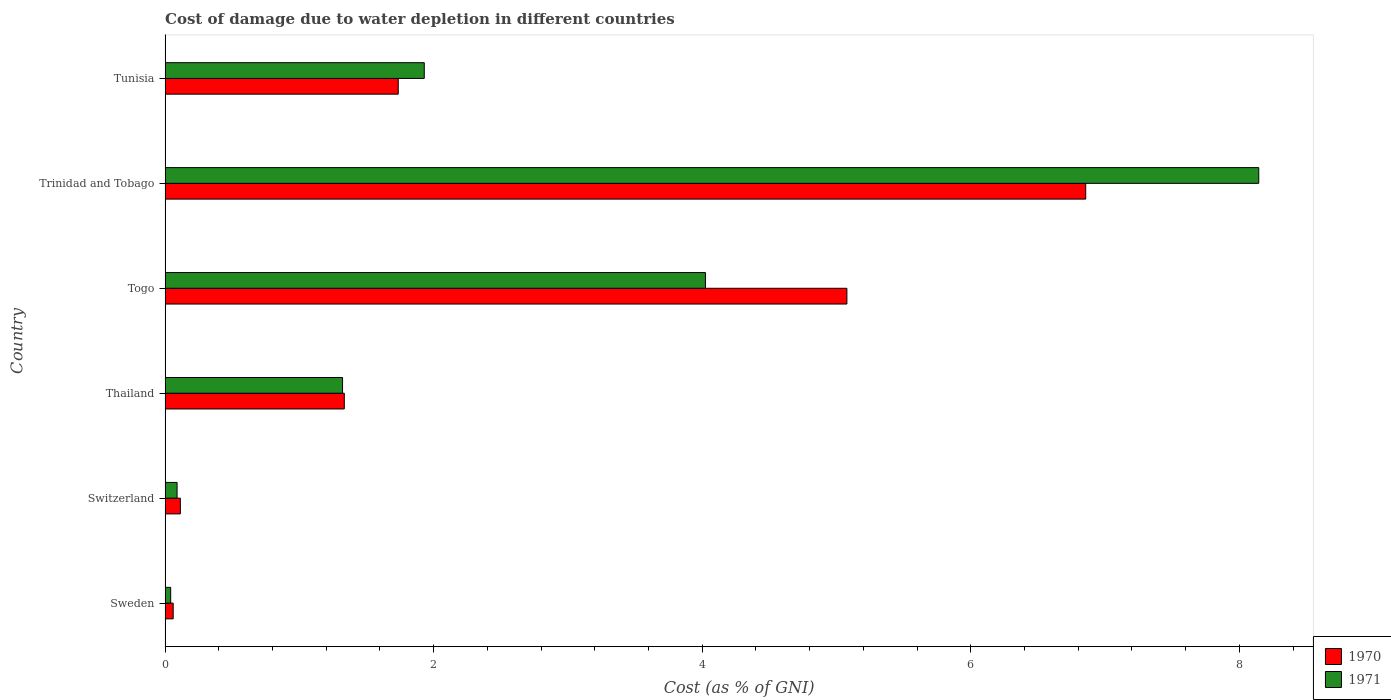Are the number of bars on each tick of the Y-axis equal?
Offer a terse response. Yes. How many bars are there on the 1st tick from the top?
Keep it short and to the point. 2. How many bars are there on the 5th tick from the bottom?
Make the answer very short. 2. What is the label of the 4th group of bars from the top?
Ensure brevity in your answer.  Thailand. What is the cost of damage caused due to water depletion in 1970 in Togo?
Provide a succinct answer. 5.08. Across all countries, what is the maximum cost of damage caused due to water depletion in 1971?
Offer a very short reply. 8.14. Across all countries, what is the minimum cost of damage caused due to water depletion in 1970?
Offer a very short reply. 0.06. In which country was the cost of damage caused due to water depletion in 1970 maximum?
Make the answer very short. Trinidad and Tobago. In which country was the cost of damage caused due to water depletion in 1971 minimum?
Provide a succinct answer. Sweden. What is the total cost of damage caused due to water depletion in 1970 in the graph?
Offer a very short reply. 15.18. What is the difference between the cost of damage caused due to water depletion in 1971 in Switzerland and that in Togo?
Make the answer very short. -3.93. What is the difference between the cost of damage caused due to water depletion in 1971 in Sweden and the cost of damage caused due to water depletion in 1970 in Togo?
Ensure brevity in your answer.  -5.04. What is the average cost of damage caused due to water depletion in 1971 per country?
Offer a terse response. 2.59. What is the difference between the cost of damage caused due to water depletion in 1970 and cost of damage caused due to water depletion in 1971 in Sweden?
Your answer should be very brief. 0.02. What is the ratio of the cost of damage caused due to water depletion in 1970 in Sweden to that in Togo?
Provide a short and direct response. 0.01. Is the cost of damage caused due to water depletion in 1970 in Togo less than that in Trinidad and Tobago?
Give a very brief answer. Yes. What is the difference between the highest and the second highest cost of damage caused due to water depletion in 1971?
Offer a terse response. 4.12. What is the difference between the highest and the lowest cost of damage caused due to water depletion in 1970?
Your answer should be compact. 6.8. In how many countries, is the cost of damage caused due to water depletion in 1970 greater than the average cost of damage caused due to water depletion in 1970 taken over all countries?
Your answer should be compact. 2. What does the 1st bar from the bottom in Trinidad and Tobago represents?
Provide a succinct answer. 1970. How many bars are there?
Provide a short and direct response. 12. Are all the bars in the graph horizontal?
Keep it short and to the point. Yes. What is the difference between two consecutive major ticks on the X-axis?
Offer a terse response. 2. Are the values on the major ticks of X-axis written in scientific E-notation?
Offer a terse response. No. Does the graph contain any zero values?
Offer a very short reply. No. What is the title of the graph?
Your answer should be compact. Cost of damage due to water depletion in different countries. What is the label or title of the X-axis?
Your response must be concise. Cost (as % of GNI). What is the label or title of the Y-axis?
Ensure brevity in your answer.  Country. What is the Cost (as % of GNI) of 1970 in Sweden?
Your answer should be compact. 0.06. What is the Cost (as % of GNI) of 1971 in Sweden?
Provide a succinct answer. 0.04. What is the Cost (as % of GNI) in 1970 in Switzerland?
Ensure brevity in your answer.  0.11. What is the Cost (as % of GNI) in 1971 in Switzerland?
Provide a short and direct response. 0.09. What is the Cost (as % of GNI) in 1970 in Thailand?
Provide a short and direct response. 1.33. What is the Cost (as % of GNI) in 1971 in Thailand?
Give a very brief answer. 1.32. What is the Cost (as % of GNI) of 1970 in Togo?
Offer a terse response. 5.08. What is the Cost (as % of GNI) of 1971 in Togo?
Make the answer very short. 4.02. What is the Cost (as % of GNI) of 1970 in Trinidad and Tobago?
Ensure brevity in your answer.  6.86. What is the Cost (as % of GNI) in 1971 in Trinidad and Tobago?
Offer a terse response. 8.14. What is the Cost (as % of GNI) in 1970 in Tunisia?
Your answer should be compact. 1.74. What is the Cost (as % of GNI) in 1971 in Tunisia?
Provide a short and direct response. 1.93. Across all countries, what is the maximum Cost (as % of GNI) of 1970?
Give a very brief answer. 6.86. Across all countries, what is the maximum Cost (as % of GNI) in 1971?
Give a very brief answer. 8.14. Across all countries, what is the minimum Cost (as % of GNI) of 1970?
Your answer should be very brief. 0.06. Across all countries, what is the minimum Cost (as % of GNI) in 1971?
Your answer should be very brief. 0.04. What is the total Cost (as % of GNI) of 1970 in the graph?
Your answer should be compact. 15.18. What is the total Cost (as % of GNI) of 1971 in the graph?
Keep it short and to the point. 15.55. What is the difference between the Cost (as % of GNI) in 1970 in Sweden and that in Switzerland?
Your answer should be very brief. -0.05. What is the difference between the Cost (as % of GNI) of 1971 in Sweden and that in Switzerland?
Offer a very short reply. -0.05. What is the difference between the Cost (as % of GNI) of 1970 in Sweden and that in Thailand?
Your answer should be very brief. -1.27. What is the difference between the Cost (as % of GNI) in 1971 in Sweden and that in Thailand?
Your answer should be compact. -1.28. What is the difference between the Cost (as % of GNI) of 1970 in Sweden and that in Togo?
Offer a very short reply. -5.02. What is the difference between the Cost (as % of GNI) of 1971 in Sweden and that in Togo?
Keep it short and to the point. -3.98. What is the difference between the Cost (as % of GNI) in 1970 in Sweden and that in Trinidad and Tobago?
Make the answer very short. -6.8. What is the difference between the Cost (as % of GNI) of 1971 in Sweden and that in Trinidad and Tobago?
Your response must be concise. -8.1. What is the difference between the Cost (as % of GNI) of 1970 in Sweden and that in Tunisia?
Offer a very short reply. -1.68. What is the difference between the Cost (as % of GNI) of 1971 in Sweden and that in Tunisia?
Keep it short and to the point. -1.89. What is the difference between the Cost (as % of GNI) in 1970 in Switzerland and that in Thailand?
Your answer should be compact. -1.22. What is the difference between the Cost (as % of GNI) of 1971 in Switzerland and that in Thailand?
Keep it short and to the point. -1.23. What is the difference between the Cost (as % of GNI) in 1970 in Switzerland and that in Togo?
Provide a succinct answer. -4.96. What is the difference between the Cost (as % of GNI) in 1971 in Switzerland and that in Togo?
Offer a very short reply. -3.93. What is the difference between the Cost (as % of GNI) of 1970 in Switzerland and that in Trinidad and Tobago?
Offer a terse response. -6.74. What is the difference between the Cost (as % of GNI) of 1971 in Switzerland and that in Trinidad and Tobago?
Keep it short and to the point. -8.05. What is the difference between the Cost (as % of GNI) of 1970 in Switzerland and that in Tunisia?
Offer a terse response. -1.62. What is the difference between the Cost (as % of GNI) in 1971 in Switzerland and that in Tunisia?
Your response must be concise. -1.84. What is the difference between the Cost (as % of GNI) of 1970 in Thailand and that in Togo?
Make the answer very short. -3.74. What is the difference between the Cost (as % of GNI) of 1971 in Thailand and that in Togo?
Offer a very short reply. -2.7. What is the difference between the Cost (as % of GNI) of 1970 in Thailand and that in Trinidad and Tobago?
Give a very brief answer. -5.52. What is the difference between the Cost (as % of GNI) in 1971 in Thailand and that in Trinidad and Tobago?
Your response must be concise. -6.82. What is the difference between the Cost (as % of GNI) in 1970 in Thailand and that in Tunisia?
Offer a terse response. -0.4. What is the difference between the Cost (as % of GNI) of 1971 in Thailand and that in Tunisia?
Keep it short and to the point. -0.61. What is the difference between the Cost (as % of GNI) in 1970 in Togo and that in Trinidad and Tobago?
Give a very brief answer. -1.78. What is the difference between the Cost (as % of GNI) of 1971 in Togo and that in Trinidad and Tobago?
Provide a short and direct response. -4.12. What is the difference between the Cost (as % of GNI) in 1970 in Togo and that in Tunisia?
Offer a very short reply. 3.34. What is the difference between the Cost (as % of GNI) of 1971 in Togo and that in Tunisia?
Your answer should be compact. 2.09. What is the difference between the Cost (as % of GNI) of 1970 in Trinidad and Tobago and that in Tunisia?
Offer a very short reply. 5.12. What is the difference between the Cost (as % of GNI) in 1971 in Trinidad and Tobago and that in Tunisia?
Provide a short and direct response. 6.21. What is the difference between the Cost (as % of GNI) of 1970 in Sweden and the Cost (as % of GNI) of 1971 in Switzerland?
Your answer should be very brief. -0.03. What is the difference between the Cost (as % of GNI) in 1970 in Sweden and the Cost (as % of GNI) in 1971 in Thailand?
Offer a terse response. -1.26. What is the difference between the Cost (as % of GNI) in 1970 in Sweden and the Cost (as % of GNI) in 1971 in Togo?
Offer a terse response. -3.96. What is the difference between the Cost (as % of GNI) of 1970 in Sweden and the Cost (as % of GNI) of 1971 in Trinidad and Tobago?
Make the answer very short. -8.08. What is the difference between the Cost (as % of GNI) in 1970 in Sweden and the Cost (as % of GNI) in 1971 in Tunisia?
Offer a terse response. -1.87. What is the difference between the Cost (as % of GNI) of 1970 in Switzerland and the Cost (as % of GNI) of 1971 in Thailand?
Your answer should be compact. -1.21. What is the difference between the Cost (as % of GNI) of 1970 in Switzerland and the Cost (as % of GNI) of 1971 in Togo?
Your answer should be very brief. -3.91. What is the difference between the Cost (as % of GNI) of 1970 in Switzerland and the Cost (as % of GNI) of 1971 in Trinidad and Tobago?
Provide a short and direct response. -8.03. What is the difference between the Cost (as % of GNI) of 1970 in Switzerland and the Cost (as % of GNI) of 1971 in Tunisia?
Provide a short and direct response. -1.82. What is the difference between the Cost (as % of GNI) in 1970 in Thailand and the Cost (as % of GNI) in 1971 in Togo?
Offer a terse response. -2.69. What is the difference between the Cost (as % of GNI) in 1970 in Thailand and the Cost (as % of GNI) in 1971 in Trinidad and Tobago?
Make the answer very short. -6.81. What is the difference between the Cost (as % of GNI) in 1970 in Thailand and the Cost (as % of GNI) in 1971 in Tunisia?
Make the answer very short. -0.6. What is the difference between the Cost (as % of GNI) of 1970 in Togo and the Cost (as % of GNI) of 1971 in Trinidad and Tobago?
Offer a very short reply. -3.07. What is the difference between the Cost (as % of GNI) in 1970 in Togo and the Cost (as % of GNI) in 1971 in Tunisia?
Keep it short and to the point. 3.15. What is the difference between the Cost (as % of GNI) in 1970 in Trinidad and Tobago and the Cost (as % of GNI) in 1971 in Tunisia?
Your answer should be compact. 4.93. What is the average Cost (as % of GNI) of 1970 per country?
Your answer should be very brief. 2.53. What is the average Cost (as % of GNI) in 1971 per country?
Your answer should be very brief. 2.59. What is the difference between the Cost (as % of GNI) of 1970 and Cost (as % of GNI) of 1971 in Sweden?
Offer a very short reply. 0.02. What is the difference between the Cost (as % of GNI) in 1970 and Cost (as % of GNI) in 1971 in Switzerland?
Your response must be concise. 0.02. What is the difference between the Cost (as % of GNI) in 1970 and Cost (as % of GNI) in 1971 in Thailand?
Offer a very short reply. 0.01. What is the difference between the Cost (as % of GNI) in 1970 and Cost (as % of GNI) in 1971 in Togo?
Offer a very short reply. 1.05. What is the difference between the Cost (as % of GNI) in 1970 and Cost (as % of GNI) in 1971 in Trinidad and Tobago?
Your answer should be very brief. -1.29. What is the difference between the Cost (as % of GNI) in 1970 and Cost (as % of GNI) in 1971 in Tunisia?
Make the answer very short. -0.19. What is the ratio of the Cost (as % of GNI) in 1970 in Sweden to that in Switzerland?
Offer a terse response. 0.53. What is the ratio of the Cost (as % of GNI) of 1971 in Sweden to that in Switzerland?
Provide a succinct answer. 0.47. What is the ratio of the Cost (as % of GNI) in 1970 in Sweden to that in Thailand?
Offer a very short reply. 0.05. What is the ratio of the Cost (as % of GNI) in 1971 in Sweden to that in Thailand?
Offer a very short reply. 0.03. What is the ratio of the Cost (as % of GNI) of 1970 in Sweden to that in Togo?
Keep it short and to the point. 0.01. What is the ratio of the Cost (as % of GNI) in 1971 in Sweden to that in Togo?
Make the answer very short. 0.01. What is the ratio of the Cost (as % of GNI) in 1970 in Sweden to that in Trinidad and Tobago?
Ensure brevity in your answer.  0.01. What is the ratio of the Cost (as % of GNI) of 1971 in Sweden to that in Trinidad and Tobago?
Provide a short and direct response. 0.01. What is the ratio of the Cost (as % of GNI) in 1970 in Sweden to that in Tunisia?
Ensure brevity in your answer.  0.03. What is the ratio of the Cost (as % of GNI) in 1971 in Sweden to that in Tunisia?
Offer a very short reply. 0.02. What is the ratio of the Cost (as % of GNI) in 1970 in Switzerland to that in Thailand?
Make the answer very short. 0.09. What is the ratio of the Cost (as % of GNI) of 1971 in Switzerland to that in Thailand?
Your answer should be compact. 0.07. What is the ratio of the Cost (as % of GNI) of 1970 in Switzerland to that in Togo?
Your response must be concise. 0.02. What is the ratio of the Cost (as % of GNI) in 1971 in Switzerland to that in Togo?
Ensure brevity in your answer.  0.02. What is the ratio of the Cost (as % of GNI) in 1970 in Switzerland to that in Trinidad and Tobago?
Ensure brevity in your answer.  0.02. What is the ratio of the Cost (as % of GNI) in 1971 in Switzerland to that in Trinidad and Tobago?
Ensure brevity in your answer.  0.01. What is the ratio of the Cost (as % of GNI) in 1970 in Switzerland to that in Tunisia?
Make the answer very short. 0.07. What is the ratio of the Cost (as % of GNI) in 1971 in Switzerland to that in Tunisia?
Your answer should be very brief. 0.05. What is the ratio of the Cost (as % of GNI) in 1970 in Thailand to that in Togo?
Ensure brevity in your answer.  0.26. What is the ratio of the Cost (as % of GNI) of 1971 in Thailand to that in Togo?
Your response must be concise. 0.33. What is the ratio of the Cost (as % of GNI) in 1970 in Thailand to that in Trinidad and Tobago?
Provide a short and direct response. 0.19. What is the ratio of the Cost (as % of GNI) in 1971 in Thailand to that in Trinidad and Tobago?
Your response must be concise. 0.16. What is the ratio of the Cost (as % of GNI) in 1970 in Thailand to that in Tunisia?
Make the answer very short. 0.77. What is the ratio of the Cost (as % of GNI) in 1971 in Thailand to that in Tunisia?
Offer a very short reply. 0.68. What is the ratio of the Cost (as % of GNI) in 1970 in Togo to that in Trinidad and Tobago?
Provide a short and direct response. 0.74. What is the ratio of the Cost (as % of GNI) of 1971 in Togo to that in Trinidad and Tobago?
Your answer should be very brief. 0.49. What is the ratio of the Cost (as % of GNI) of 1970 in Togo to that in Tunisia?
Ensure brevity in your answer.  2.92. What is the ratio of the Cost (as % of GNI) in 1971 in Togo to that in Tunisia?
Your answer should be very brief. 2.08. What is the ratio of the Cost (as % of GNI) in 1970 in Trinidad and Tobago to that in Tunisia?
Provide a succinct answer. 3.95. What is the ratio of the Cost (as % of GNI) in 1971 in Trinidad and Tobago to that in Tunisia?
Your answer should be compact. 4.22. What is the difference between the highest and the second highest Cost (as % of GNI) of 1970?
Your answer should be compact. 1.78. What is the difference between the highest and the second highest Cost (as % of GNI) of 1971?
Offer a very short reply. 4.12. What is the difference between the highest and the lowest Cost (as % of GNI) of 1970?
Keep it short and to the point. 6.8. What is the difference between the highest and the lowest Cost (as % of GNI) in 1971?
Ensure brevity in your answer.  8.1. 